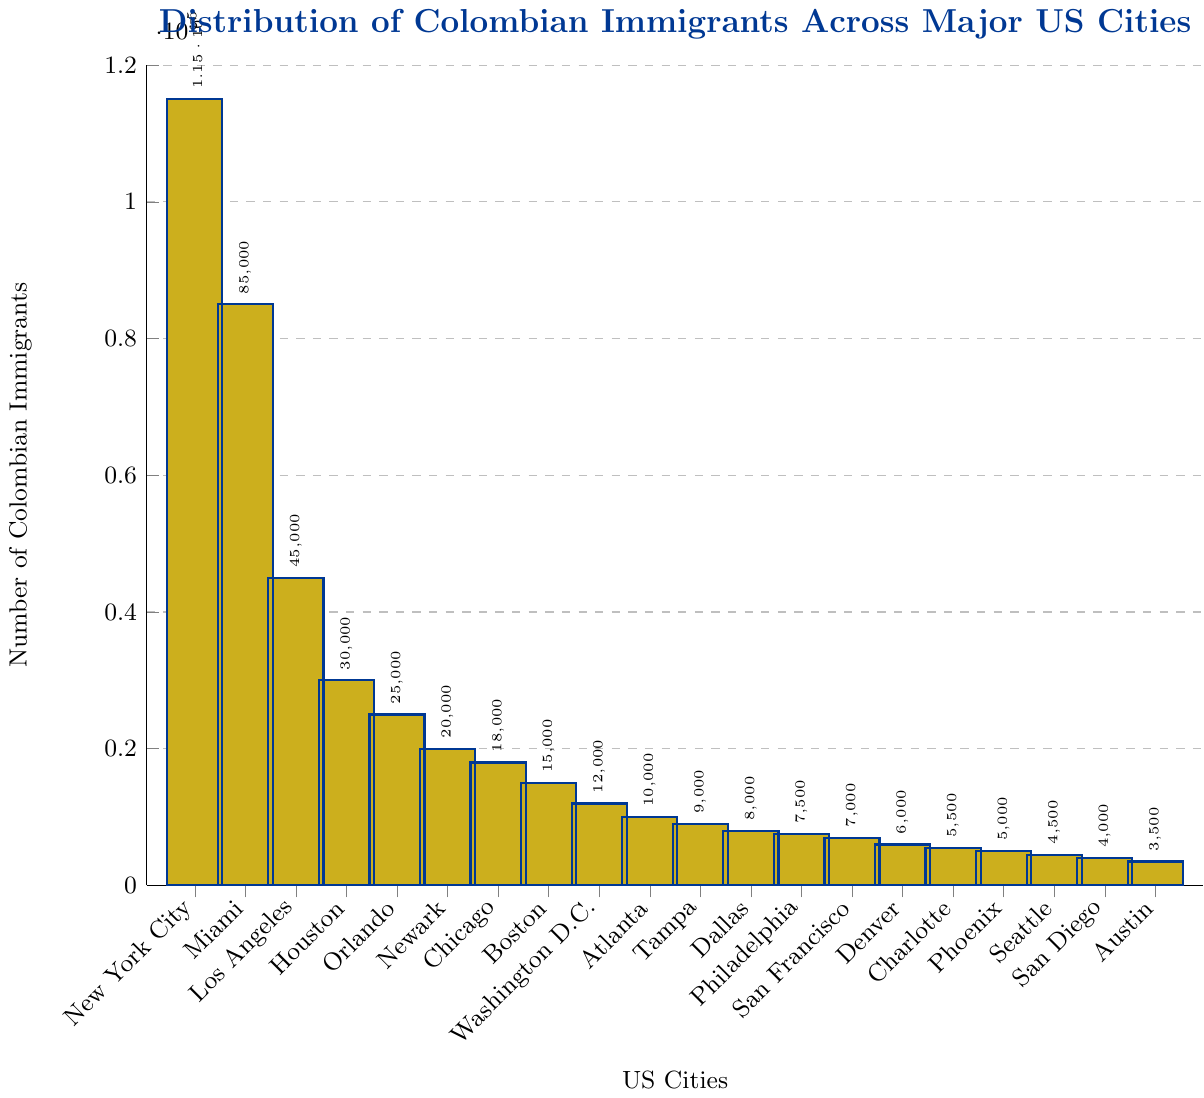What is the city with the highest number of Colombian immigrants? The tallest bar represents New York City, indicating it has the highest number of Colombian immigrants at 115,000.
Answer: New York City Which city has more Colombian immigrants: Miami or Los Angeles? Comparing the height of the bars for Miami and Los Angeles, Miami's bar is higher with 85,000 immigrants compared to Los Angeles' 45,000.
Answer: Miami What is the combined number of Colombian immigrants in Houston and Orlando? The bar for Houston shows 30,000 immigrants and the bar for Orlando shows 25,000. Adding these gives 30,000 + 25,000 = 55,000.
Answer: 55,000 How many more Colombian immigrants are there in New York City compared to Atlanta? New York City has 115,000 immigrants while Atlanta has 10,000. The difference is 115,000 - 10,000 = 105,000.
Answer: 105,000 What percentage of the total number of Colombian immigrants reside in New York City, if the total number is calculated? First, sum all the immigrant numbers: 115,000 + 85,000 + 45,000 + 30,000 + 25,000 + 20,000 + 18,000 + 15,000 + 12,000 + 10,000 + 9,000 + 8,000 + 7,500 + 7,000 + 6,000 + 5,500 + 5,000 + 4,500 + 4,000 + 3,500 = 460,000. The percentage for New York City is (115,000 / 460,000) * 100 ≈ 25%.
Answer: 25% Which city has the lowest number of Colombian immigrants, and how many? The shortest bar represents Austin, indicating it has the lowest number of Colombian immigrants at 3,500.
Answer: Austin, 3,500 Compare the sum of Colombian immigrants in the top 3 cities (New York City, Miami, Los Angeles) and the sum of the bottom 3 cities (San Diego, Austin, Denver). Which sum is greater and by how much? The sum of the top 3: 115,000 (NYC) + 85,000 (Miami) + 45,000 (LA) = 245,000. The sum of the bottom 3: 4,000 (San Diego) + 3,500 (Austin) + 6,000 (Denver) = 13,500. The difference is 245,000 - 13,500 = 231,500.
Answer: Top 3 cities by 231,500 